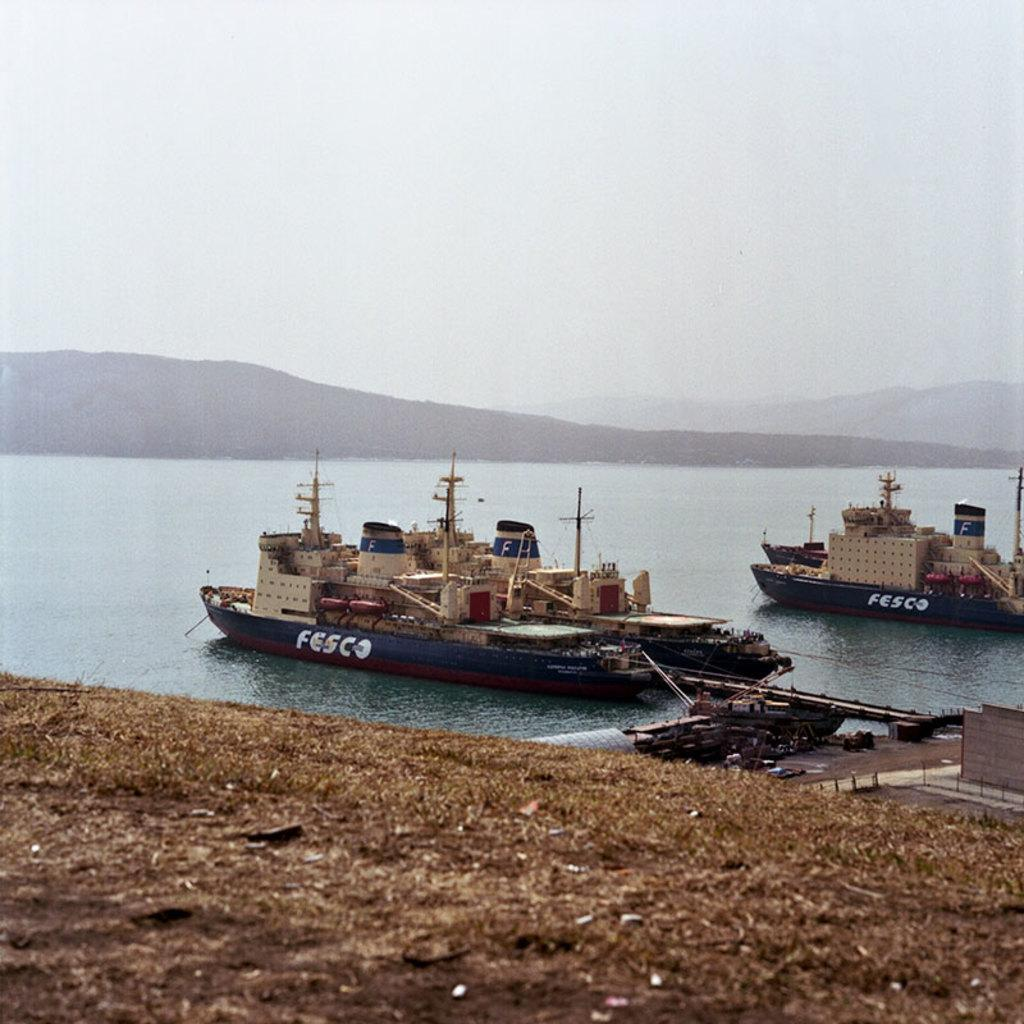<image>
Offer a succinct explanation of the picture presented. Two boats that say FESCO on the side sit in the calm waters 